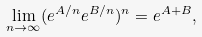Convert formula to latex. <formula><loc_0><loc_0><loc_500><loc_500>\lim _ { n \to \infty } ( e ^ { A / n } e ^ { B / n } ) ^ { n } = e ^ { A + B } ,</formula> 